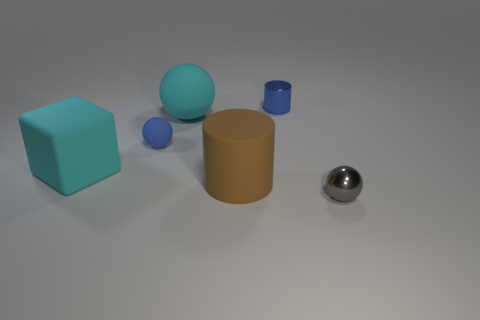What is the material of the ball that is the same size as the brown matte thing?
Offer a very short reply. Rubber. Are there fewer gray objects that are on the left side of the metal sphere than big matte objects that are to the right of the tiny rubber sphere?
Provide a succinct answer. Yes. What shape is the brown rubber object that is in front of the blue thing behind the blue ball?
Offer a terse response. Cylinder. Are any large gray metal blocks visible?
Ensure brevity in your answer.  No. What color is the tiny sphere to the right of the tiny blue shiny cylinder?
Provide a succinct answer. Gray. There is a small thing that is the same color as the small rubber ball; what is it made of?
Give a very brief answer. Metal. There is a small blue metallic object; are there any balls on the right side of it?
Your answer should be very brief. Yes. Is the number of big brown things greater than the number of large metallic blocks?
Make the answer very short. Yes. The thing that is on the right side of the small blue object right of the cylinder that is on the left side of the blue metal cylinder is what color?
Offer a terse response. Gray. There is a large cylinder that is the same material as the big cube; what color is it?
Keep it short and to the point. Brown. 